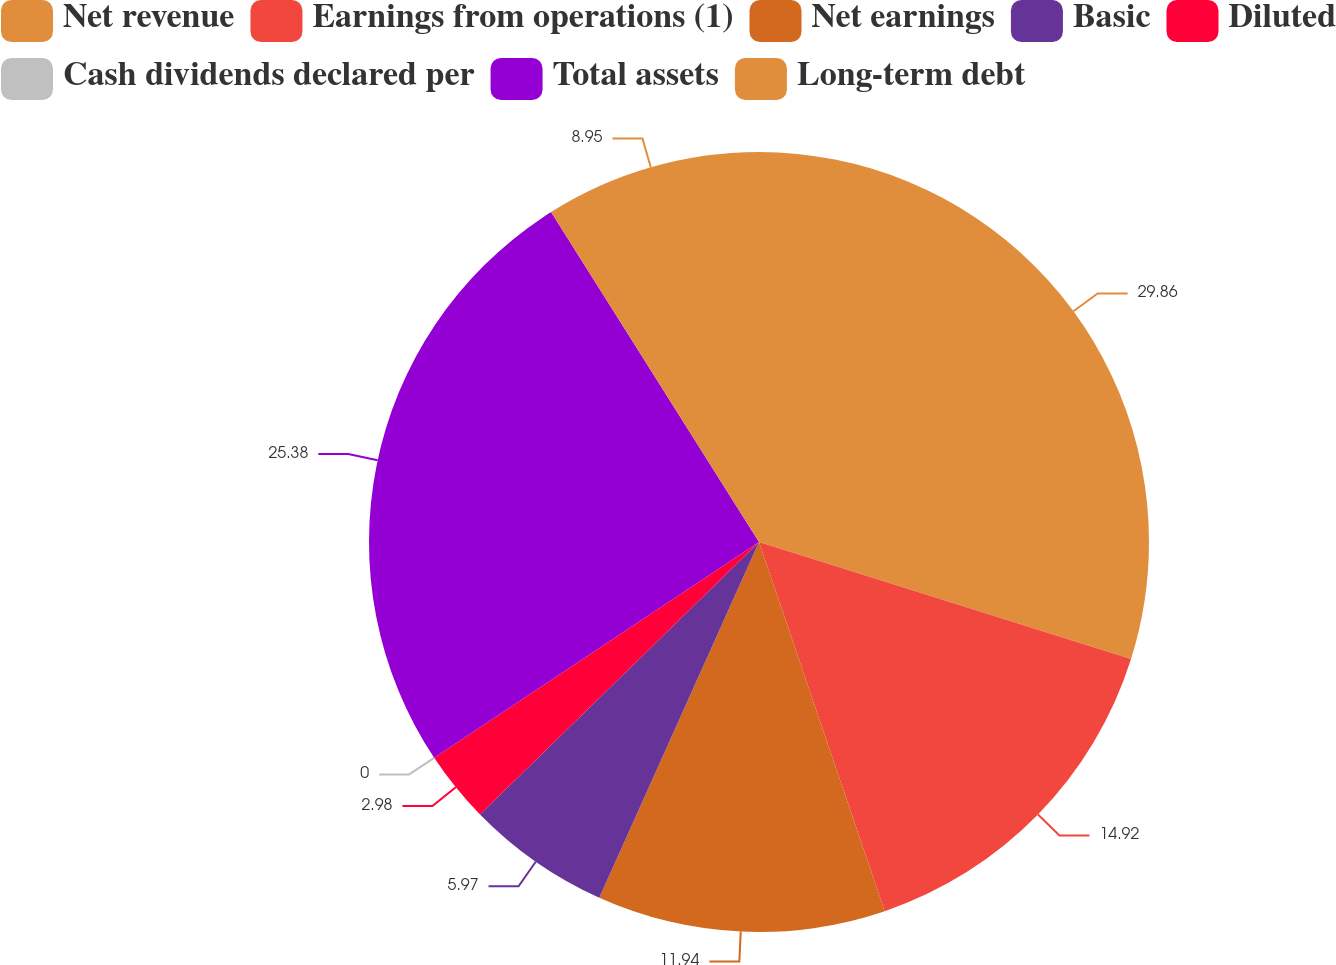<chart> <loc_0><loc_0><loc_500><loc_500><pie_chart><fcel>Net revenue<fcel>Earnings from operations (1)<fcel>Net earnings<fcel>Basic<fcel>Diluted<fcel>Cash dividends declared per<fcel>Total assets<fcel>Long-term debt<nl><fcel>29.85%<fcel>14.92%<fcel>11.94%<fcel>5.97%<fcel>2.98%<fcel>0.0%<fcel>25.38%<fcel>8.95%<nl></chart> 